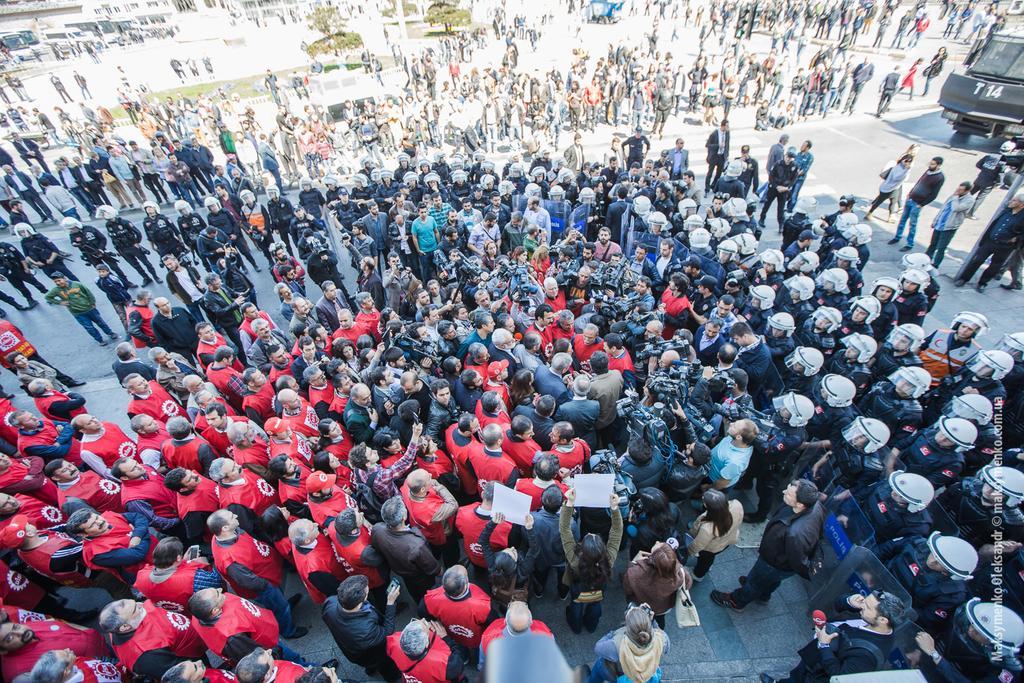How would you summarize this image in a sentence or two? In this in the middle I can see there are many people gather, and at the back there are many policemen standing. 